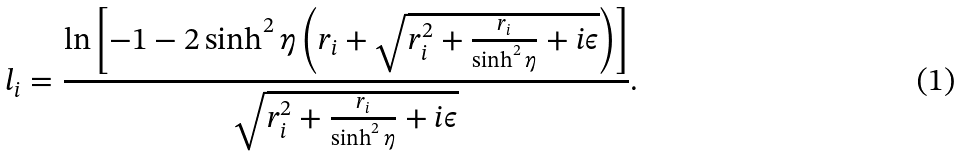Convert formula to latex. <formula><loc_0><loc_0><loc_500><loc_500>l _ { i } = { \frac { \ln \left [ - 1 - 2 \sinh ^ { 2 } \eta \left ( r _ { i } + \sqrt { r _ { i } ^ { 2 } + { \frac { r _ { i } } { \sinh ^ { 2 } \eta } } + i \epsilon } \right ) \right ] } { \sqrt { r _ { i } ^ { 2 } + { \frac { r _ { i } } { \sinh ^ { 2 } \eta } } + i \epsilon } } } .</formula> 